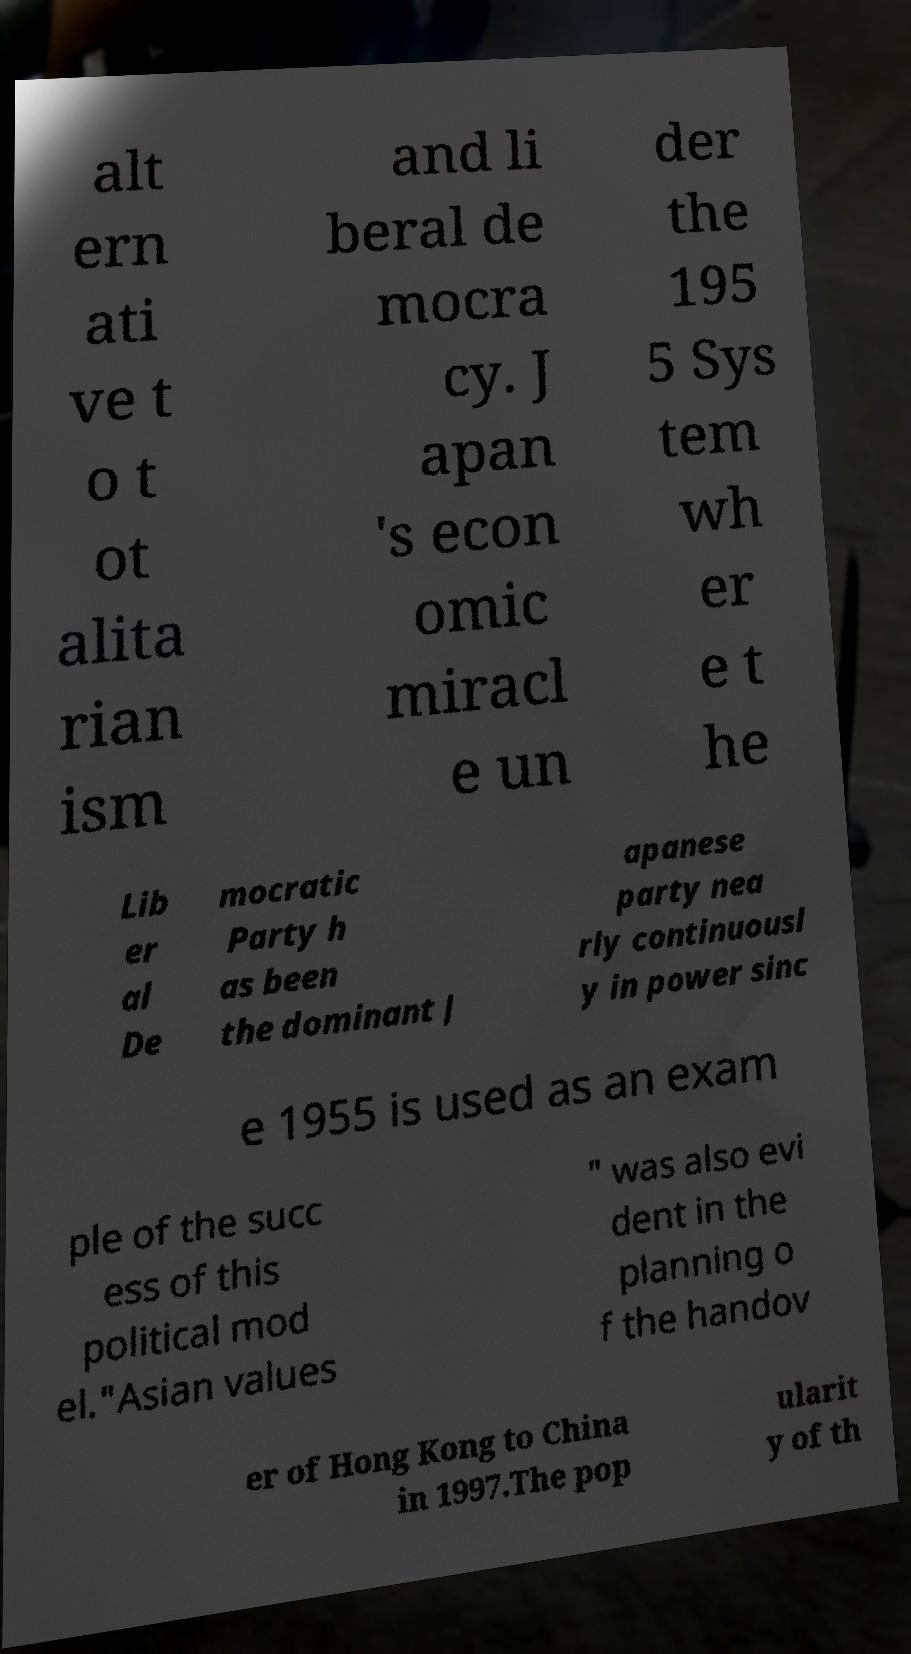Can you read and provide the text displayed in the image?This photo seems to have some interesting text. Can you extract and type it out for me? alt ern ati ve t o t ot alita rian ism and li beral de mocra cy. J apan 's econ omic miracl e un der the 195 5 Sys tem wh er e t he Lib er al De mocratic Party h as been the dominant J apanese party nea rly continuousl y in power sinc e 1955 is used as an exam ple of the succ ess of this political mod el."Asian values " was also evi dent in the planning o f the handov er of Hong Kong to China in 1997.The pop ularit y of th 